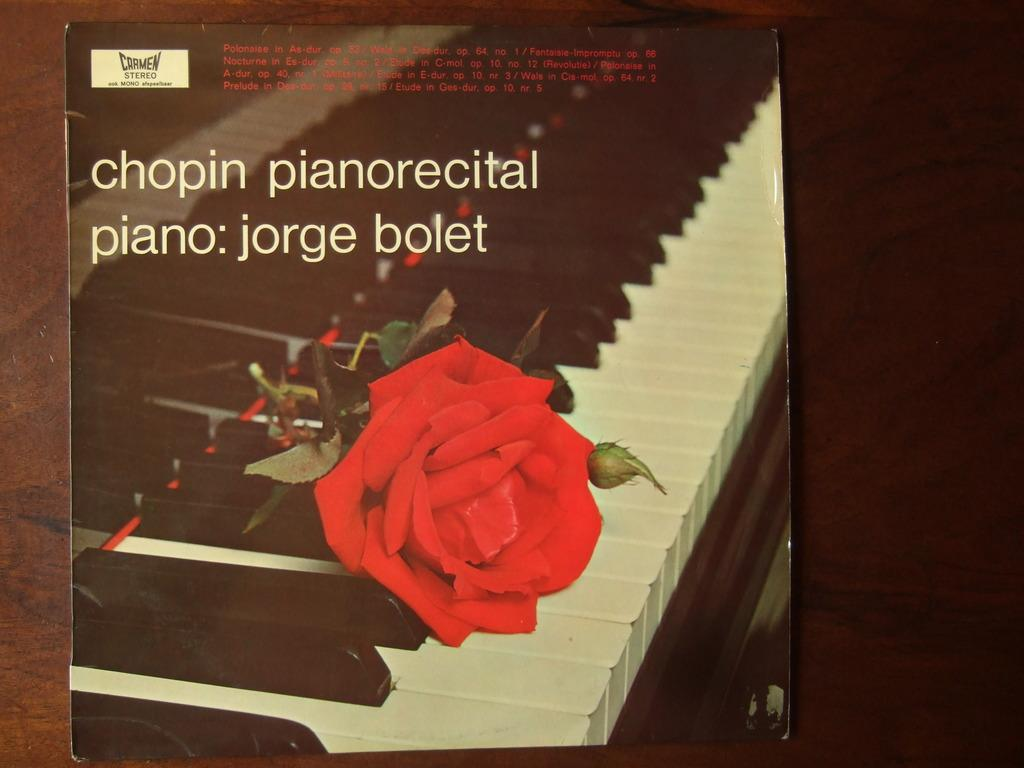What type of flower is in the image? There is a red color rose in the image. Where is the red color rose located? The red color rose is on a musical keyboard. What type of seed is visible in the image? There is no seed visible in the image; it features a red color rose on a musical keyboard. What invention is being used to create clouds in the image? There are no clouds or inventions related to creating clouds present in the image. 